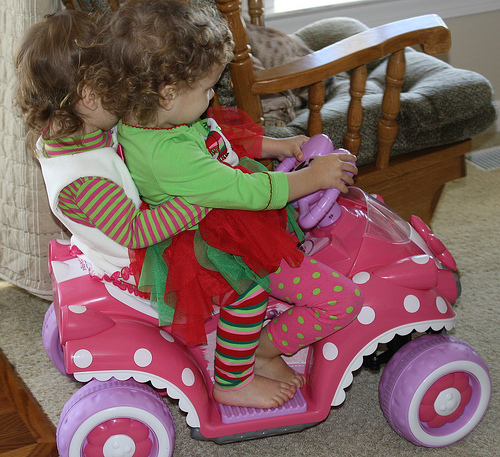<image>
Is the child on the child? Yes. Looking at the image, I can see the child is positioned on top of the child, with the child providing support. Is the cat under the chair? No. The cat is not positioned under the chair. The vertical relationship between these objects is different. 